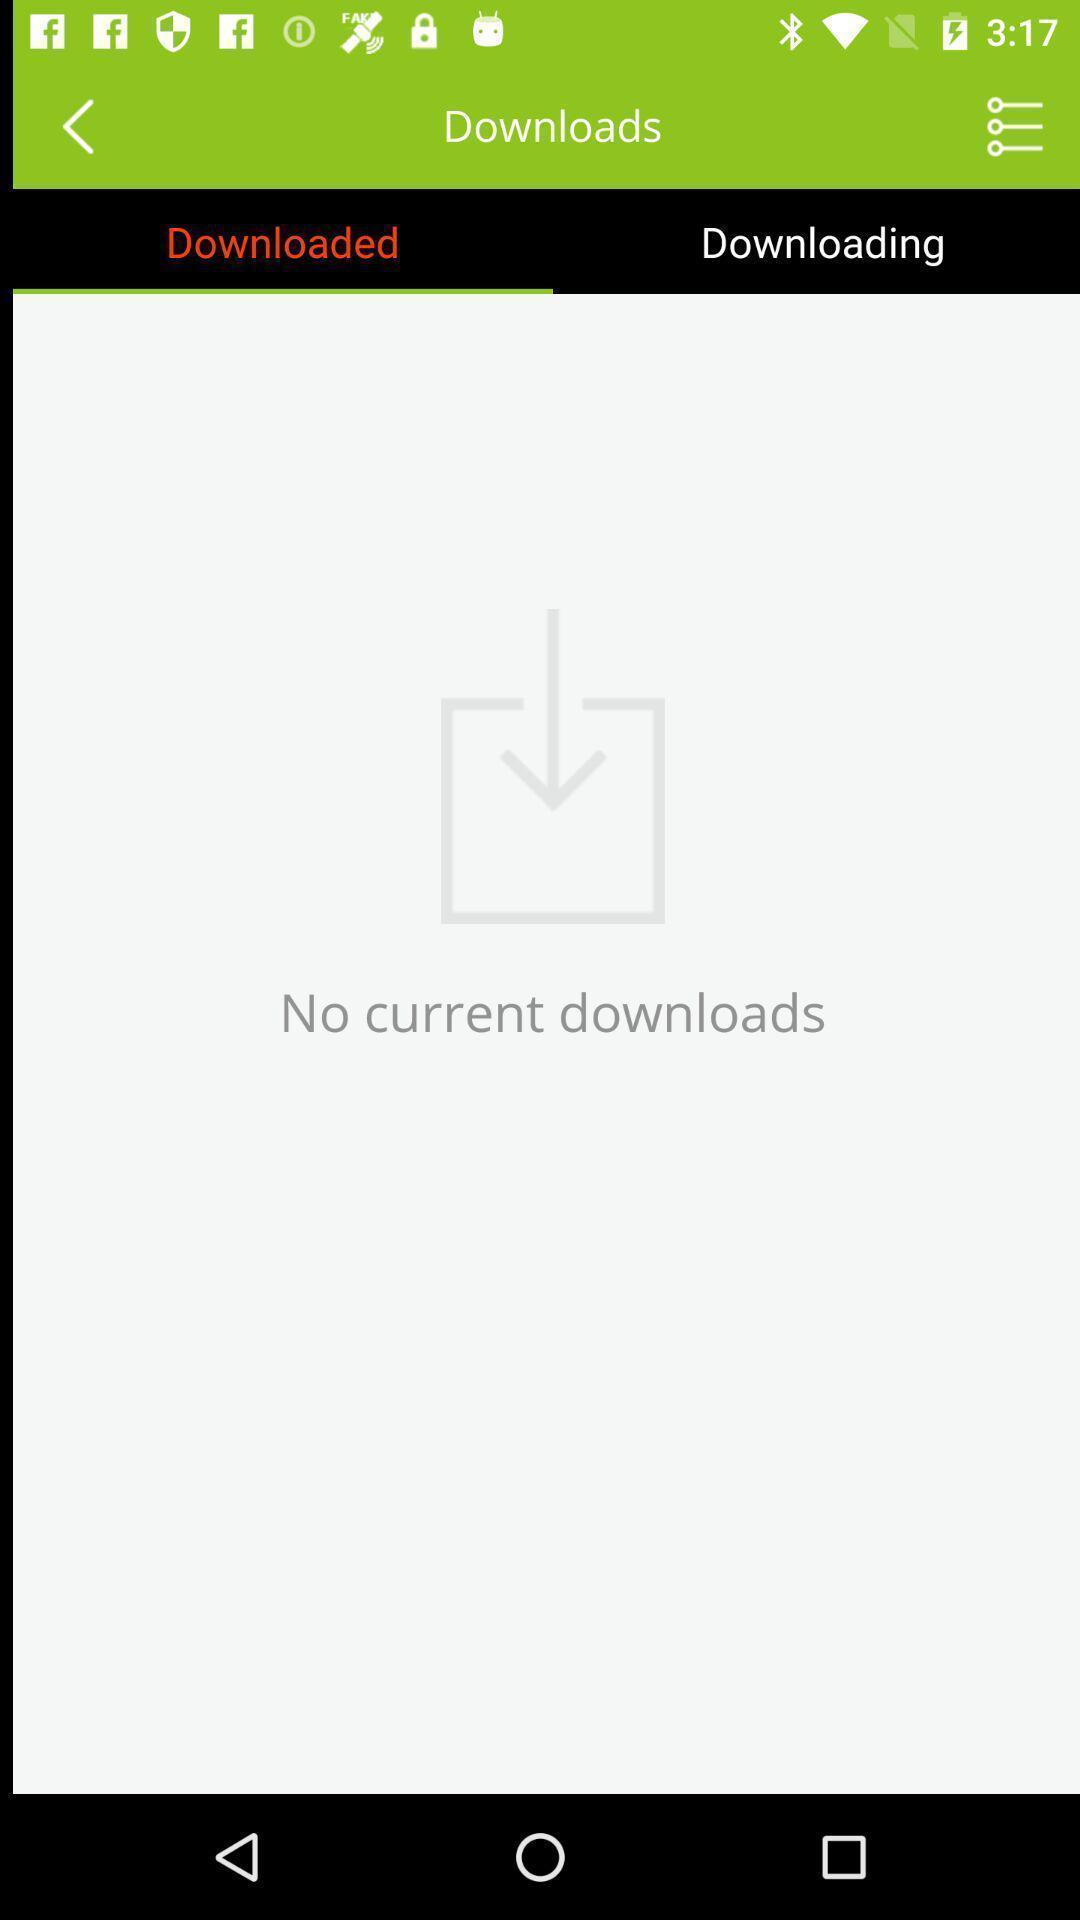Provide a textual representation of this image. Screen shows download details. 